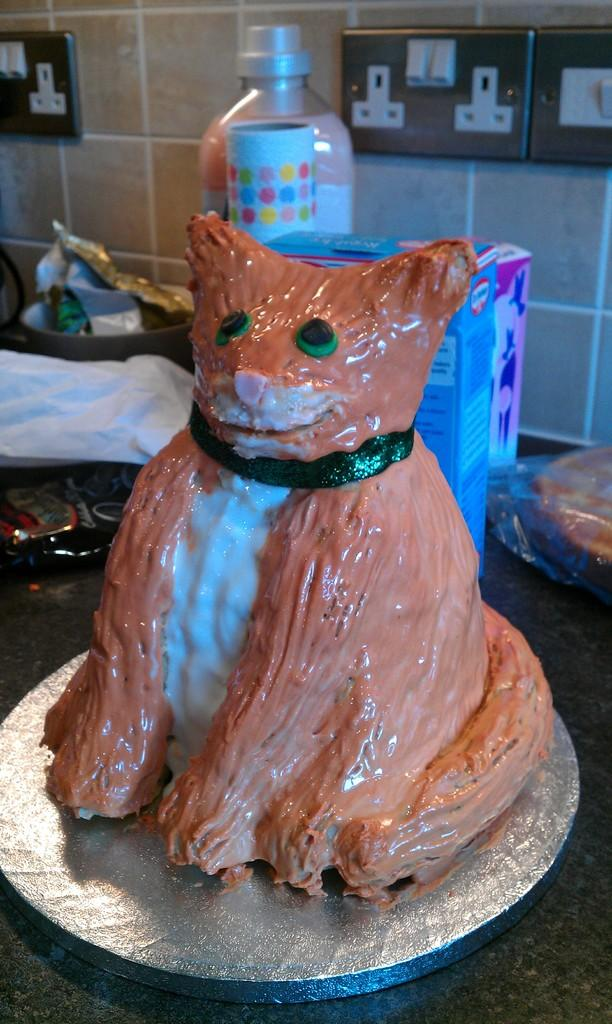What type of drink container is visible in the image? There is a coke bottle in the image. What other objects can be seen in the image? There are boxes, packets, and a box with food in it visible in the image. Where are the objects located in the image? The objects are on a kitchen platform. What can be seen on the wall in the background? The wall has tiles in the background. What else is visible in the background? There are sockets visible in the background. What type of jewel can be seen in the image? There is no jewel present in the image. What shape is the playground in the image? There is no playground present in the image. 